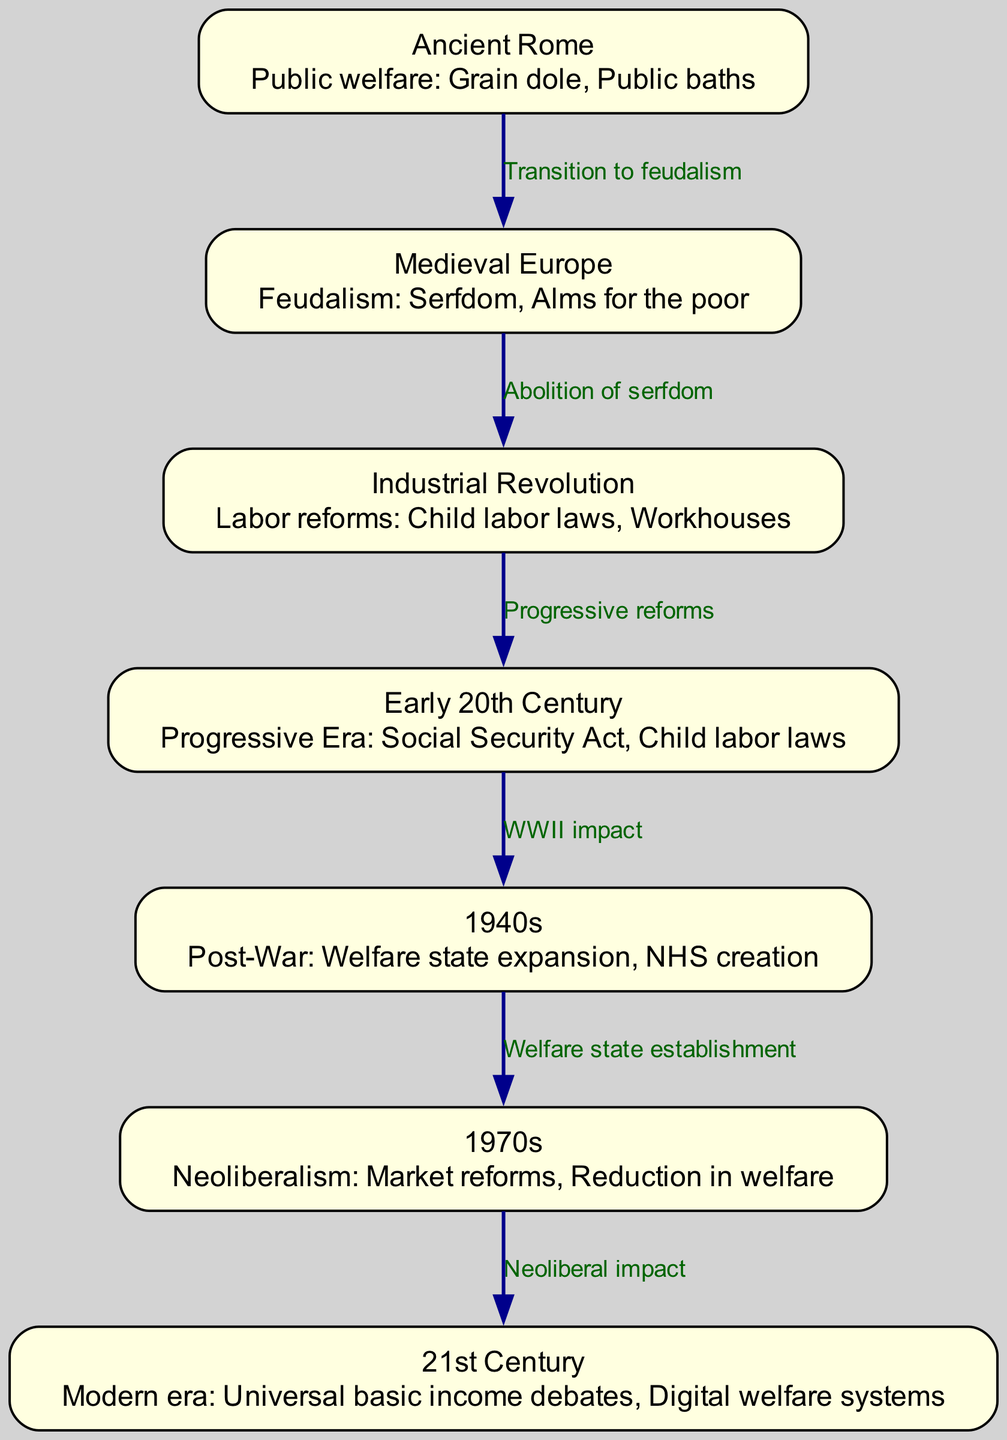What is the label of the node representing the Medieval Europe era? The node that corresponds to Medieval Europe is labeled "Medieval Europe". This is directly found in the nodes section of the diagram.
Answer: Medieval Europe How many nodes are there in the diagram? By counting the nodes listed in the data, there are a total of 7 distinct nodes representing different eras of social policy evolution.
Answer: 7 What are the two social policies listed for Ancient Rome? In the description of the Ancient Rome node, it specifies two policies: "Grain dole" and "Public baths". This information directly describes the public welfare aspects of that era.
Answer: Grain dole, Public baths Which era follows the Industrial Revolution according to the diagram? The edge that transitions from the Industrial Revolution node points to the Early 20th Century node, indicating that this is the next era in the evolution of social policies.
Answer: Early 20th Century What kind of reforms are associated with the Early 20th Century era? The node for the Early 20th Century indicates a "Progressive Era” which includes the "Social Security Act" and the continuation of "Child labor laws". This highlights the types of reforms that characterize this period.
Answer: Progressive Era: Social Security Act, Child labor laws Which era is described as having "Welfare state expansion"? The node labeled "1940s" describes that period as one of "Welfare state expansion". This information comes directly from the description associated with that node in the diagram.
Answer: 1940s What is the main characteristic of social policies in the 1970s? The node for the 1970s specifies "Neoliberalism: Market reforms, Reduction in welfare". This indicates the focus during that era on market-oriented policies and a decrease in welfare programs.
Answer: Neoliberalism: Market reforms, Reduction in welfare How do the 1940s and 1970s compare in terms of their social policy characteristics? In the 1940s, the diagram indicates the establishment of the welfare state, whereas in the 1970s, there was a shift towards Neoliberalism, marked by market reforms and a reduction in welfare programs, indicating a significant change in focus.
Answer: Establishment of welfare state vs. Neoliberalism Which transition indicates the move from serfdom to more modern labor laws? The edge from Medieval Europe to the Industrial Revolution represents a significant transition in social policy marked by the "Abolition of serfdom". This indicates a crucial shift from the feudal system to industrial labor reforms.
Answer: Abolition of serfdom 